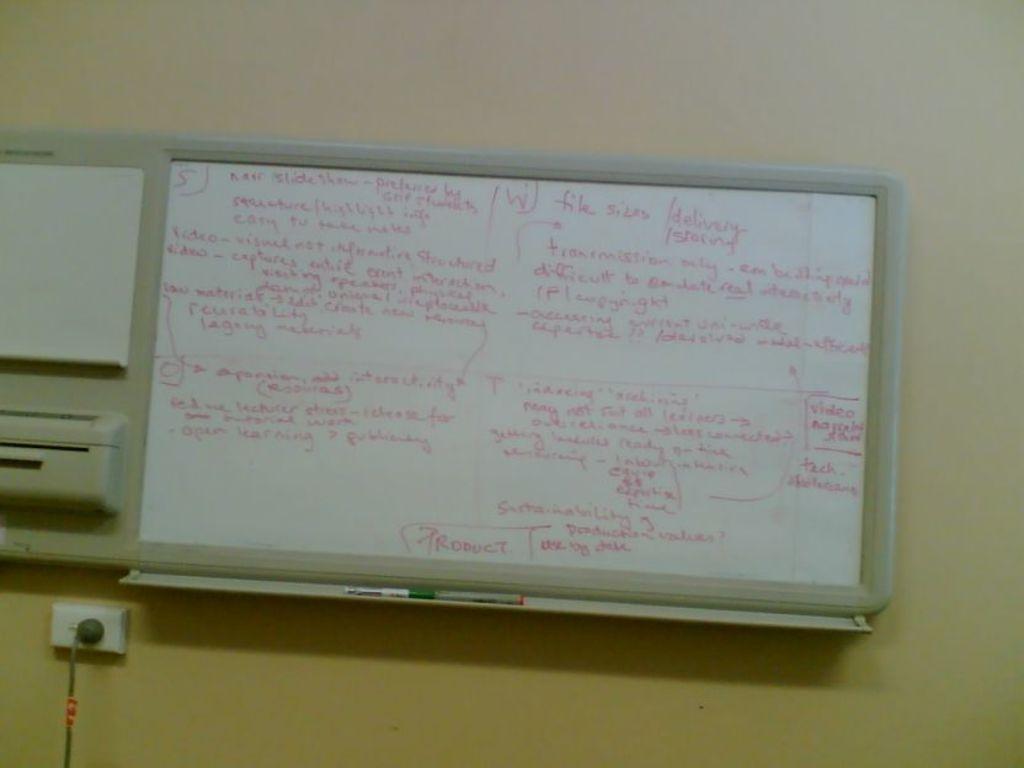Can you describe this image briefly? In this picture we can see board, switch board and objects on the wall and we can see cable. 